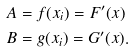<formula> <loc_0><loc_0><loc_500><loc_500>A & = f ( x _ { i } ) = F ^ { \prime } ( x ) \\ B & = g ( x _ { i } ) = G ^ { \prime } ( x ) .</formula> 